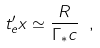Convert formula to latex. <formula><loc_0><loc_0><loc_500><loc_500>t ^ { \prime } _ { e } x \simeq \frac { R } { \Gamma _ { * } c } \ ,</formula> 